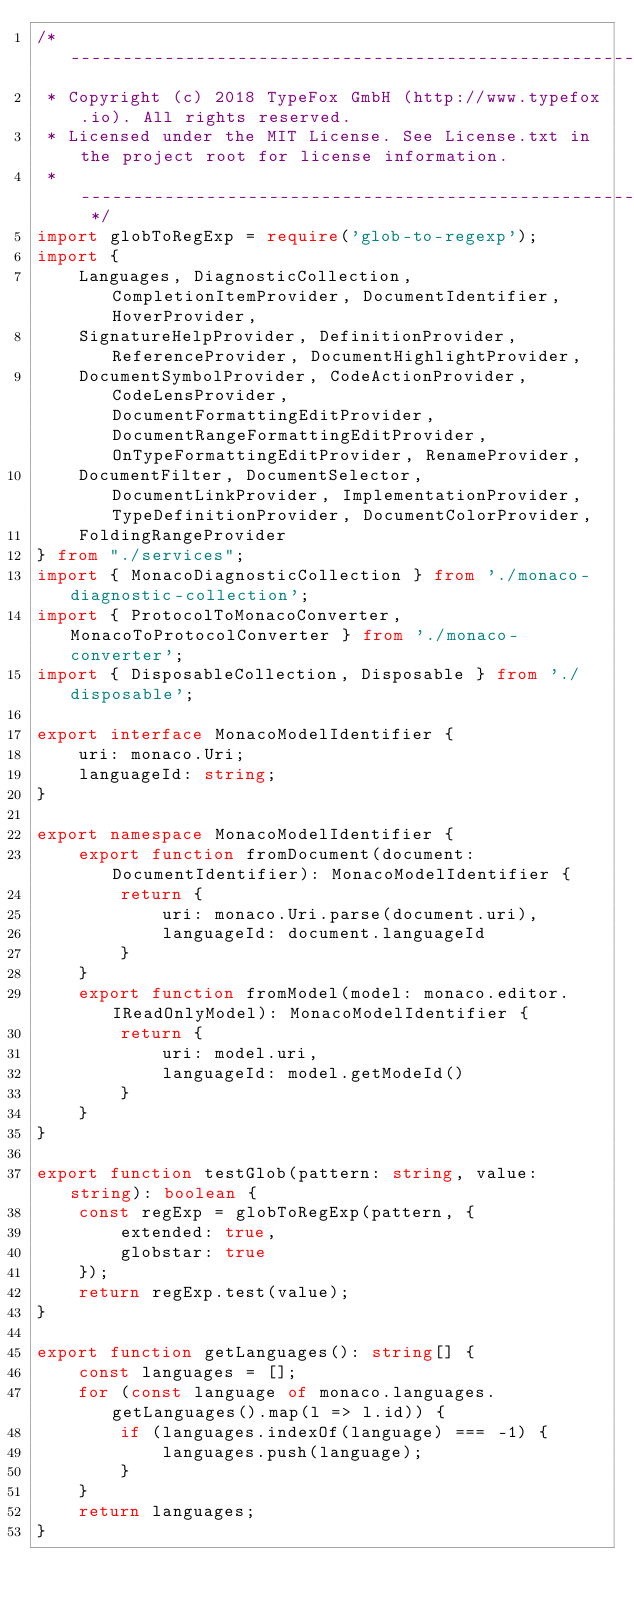Convert code to text. <code><loc_0><loc_0><loc_500><loc_500><_TypeScript_>/* --------------------------------------------------------------------------------------------
 * Copyright (c) 2018 TypeFox GmbH (http://www.typefox.io). All rights reserved.
 * Licensed under the MIT License. See License.txt in the project root for license information.
 * ------------------------------------------------------------------------------------------ */
import globToRegExp = require('glob-to-regexp');
import {
    Languages, DiagnosticCollection, CompletionItemProvider, DocumentIdentifier, HoverProvider,
    SignatureHelpProvider, DefinitionProvider, ReferenceProvider, DocumentHighlightProvider,
    DocumentSymbolProvider, CodeActionProvider, CodeLensProvider, DocumentFormattingEditProvider, DocumentRangeFormattingEditProvider, OnTypeFormattingEditProvider, RenameProvider,
    DocumentFilter, DocumentSelector, DocumentLinkProvider, ImplementationProvider, TypeDefinitionProvider, DocumentColorProvider,
    FoldingRangeProvider
} from "./services";
import { MonacoDiagnosticCollection } from './monaco-diagnostic-collection';
import { ProtocolToMonacoConverter, MonacoToProtocolConverter } from './monaco-converter';
import { DisposableCollection, Disposable } from './disposable';

export interface MonacoModelIdentifier {
    uri: monaco.Uri;
    languageId: string;
}

export namespace MonacoModelIdentifier {
    export function fromDocument(document: DocumentIdentifier): MonacoModelIdentifier {
        return {
            uri: monaco.Uri.parse(document.uri),
            languageId: document.languageId
        }
    }
    export function fromModel(model: monaco.editor.IReadOnlyModel): MonacoModelIdentifier {
        return {
            uri: model.uri,
            languageId: model.getModeId()
        }
    }
}

export function testGlob(pattern: string, value: string): boolean {
    const regExp = globToRegExp(pattern, {
        extended: true,
        globstar: true
    });
    return regExp.test(value);
}

export function getLanguages(): string[] {
    const languages = [];
    for (const language of monaco.languages.getLanguages().map(l => l.id)) {
        if (languages.indexOf(language) === -1) {
            languages.push(language);
        }
    }
    return languages;
}
</code> 